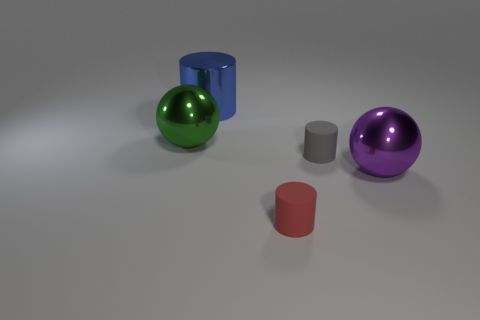Subtract all small red rubber cylinders. How many cylinders are left? 2 Add 5 gray rubber cylinders. How many objects exist? 10 Subtract all gray cylinders. How many cylinders are left? 2 Subtract 3 cylinders. How many cylinders are left? 0 Subtract all cylinders. How many objects are left? 2 Subtract all green cubes. How many gray spheres are left? 0 Subtract all yellow cylinders. Subtract all yellow balls. How many cylinders are left? 3 Subtract all metal objects. Subtract all large purple metallic objects. How many objects are left? 1 Add 5 small rubber cylinders. How many small rubber cylinders are left? 7 Add 3 gray matte cylinders. How many gray matte cylinders exist? 4 